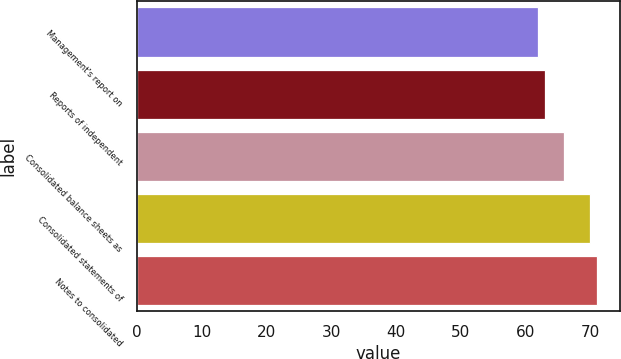Convert chart. <chart><loc_0><loc_0><loc_500><loc_500><bar_chart><fcel>Management's report on<fcel>Reports of independent<fcel>Consolidated balance sheets as<fcel>Consolidated statements of<fcel>Notes to consolidated<nl><fcel>62<fcel>63<fcel>66<fcel>70<fcel>71<nl></chart> 